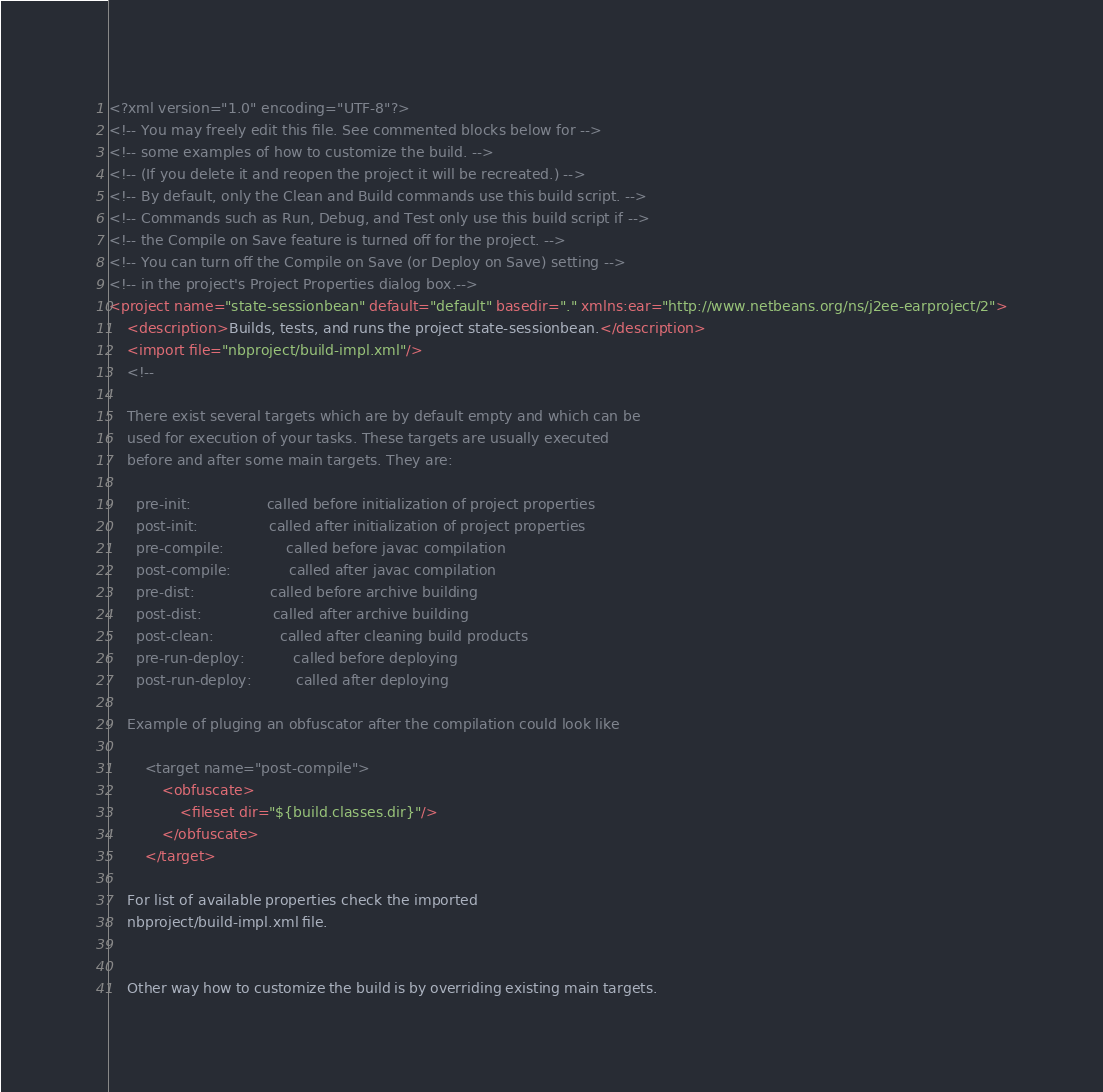<code> <loc_0><loc_0><loc_500><loc_500><_XML_><?xml version="1.0" encoding="UTF-8"?>
<!-- You may freely edit this file. See commented blocks below for -->
<!-- some examples of how to customize the build. -->
<!-- (If you delete it and reopen the project it will be recreated.) -->
<!-- By default, only the Clean and Build commands use this build script. -->
<!-- Commands such as Run, Debug, and Test only use this build script if -->
<!-- the Compile on Save feature is turned off for the project. -->
<!-- You can turn off the Compile on Save (or Deploy on Save) setting -->
<!-- in the project's Project Properties dialog box.-->
<project name="state-sessionbean" default="default" basedir="." xmlns:ear="http://www.netbeans.org/ns/j2ee-earproject/2">
    <description>Builds, tests, and runs the project state-sessionbean.</description>
    <import file="nbproject/build-impl.xml"/>
    <!--

    There exist several targets which are by default empty and which can be 
    used for execution of your tasks. These targets are usually executed 
    before and after some main targets. They are: 

      pre-init:                 called before initialization of project properties 
      post-init:                called after initialization of project properties 
      pre-compile:              called before javac compilation 
      post-compile:             called after javac compilation 
      pre-dist:                 called before archive building 
      post-dist:                called after archive building 
      post-clean:               called after cleaning build products 
      pre-run-deploy:           called before deploying
      post-run-deploy:          called after deploying

    Example of pluging an obfuscator after the compilation could look like 

        <target name="post-compile">
            <obfuscate>
                <fileset dir="${build.classes.dir}"/>
            </obfuscate>
        </target>

    For list of available properties check the imported 
    nbproject/build-impl.xml file. 


    Other way how to customize the build is by overriding existing main targets.</code> 